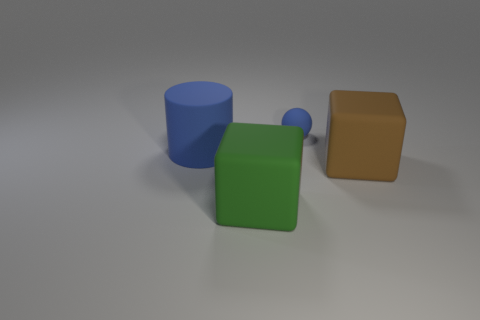Add 2 matte blocks. How many objects exist? 6 Subtract all balls. How many objects are left? 3 Add 1 large red rubber cylinders. How many large red rubber cylinders exist? 1 Subtract 0 blue blocks. How many objects are left? 4 Subtract all purple objects. Subtract all large green things. How many objects are left? 3 Add 2 small rubber spheres. How many small rubber spheres are left? 3 